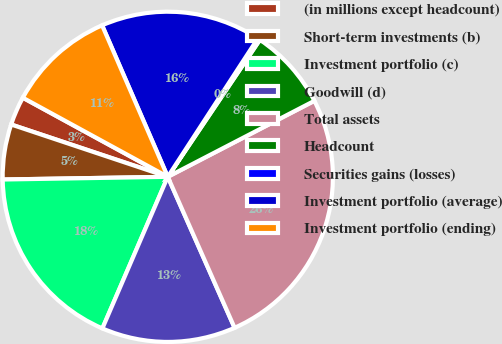<chart> <loc_0><loc_0><loc_500><loc_500><pie_chart><fcel>(in millions except headcount)<fcel>Short-term investments (b)<fcel>Investment portfolio (c)<fcel>Goodwill (d)<fcel>Total assets<fcel>Headcount<fcel>Securities gains (losses)<fcel>Investment portfolio (average)<fcel>Investment portfolio (ending)<nl><fcel>2.82%<fcel>5.39%<fcel>18.26%<fcel>13.11%<fcel>25.98%<fcel>7.97%<fcel>0.24%<fcel>15.69%<fcel>10.54%<nl></chart> 